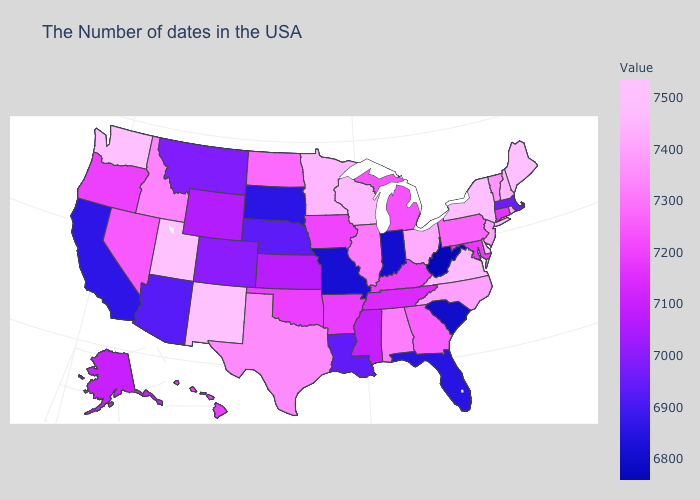Is the legend a continuous bar?
Quick response, please. Yes. Among the states that border South Dakota , which have the lowest value?
Be succinct. Nebraska. 